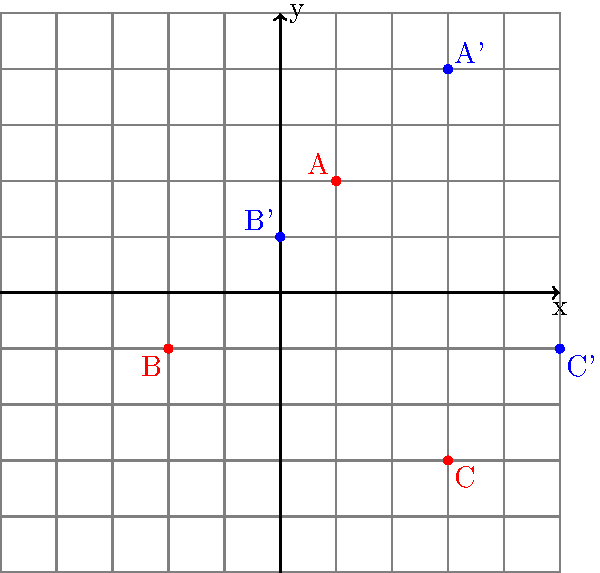The map shows the original locations of three coal mines (A, B, and C) in red and their new positions (A', B', and C') in blue after a translation. What is the translation vector that describes this transformation? To find the translation vector, we need to determine how each point has moved:

1. For point A:
   Original position: (1, 2)
   New position (A'): (3, 4)
   Movement: (3-1, 4-2) = (2, 2)

2. For point B:
   Original position: (-2, -1)
   New position (B'): (0, 1)
   Movement: (0-(-2), 1-(-1)) = (2, 2)

3. For point C:
   Original position: (3, -3)
   New position (C'): (5, -1)
   Movement: (5-3, -1-(-3)) = (2, 2)

We can see that all points have moved by the same amount: 2 units to the right and 2 units up. This consistent movement is represented by the vector (2, 2).

In mathematical notation, the translation can be described as:
$T(x, y) = (x+2, y+2)$

Therefore, the translation vector is $\vec{v} = (2, 2)$.
Answer: $(2, 2)$ 